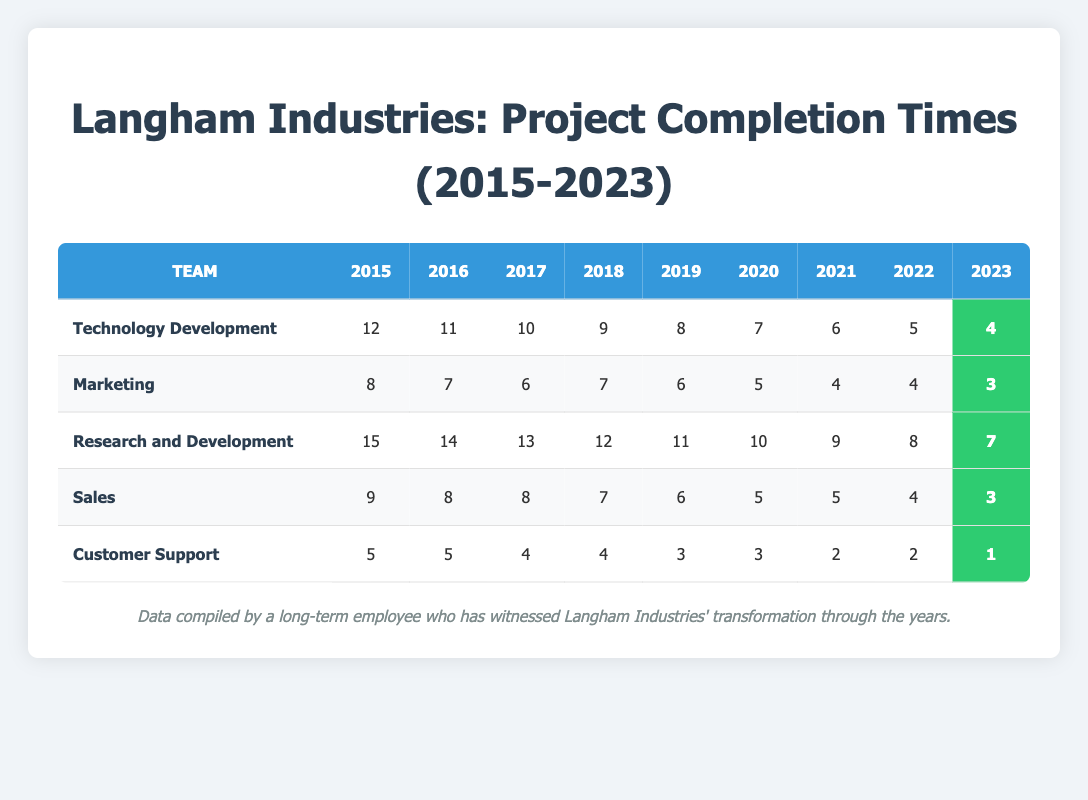What is the average project completion time for the Marketing team in 2023? The completion time for Marketing in 2023 is directly available in the table as 3.
Answer: 3 Which team had the longest average project completion time in 2015? Looking at the table, the Research and Development team had a completion time of 15 in 2015, which is the highest among all teams.
Answer: Research and Development What is the total project completion time for the Technology Development team from 2015 to 2023? Summing the completion times for Technology Development: 12 + 11 + 10 + 9 + 8 + 7 + 6 + 5 + 4 = 72.
Answer: 72 Did the Customer Support team improve their project completion time from 2015 to 2023? In 2015, the time was 5, and it decreased to 1 in 2023, indicating a significant improvement in efficiency.
Answer: Yes What was the difference in project completion times between the Marketing team and the Sales team in 2022? The completion time for Marketing in 2022 is 4, and for Sales, it is also 4. The difference is 4 - 4 = 0.
Answer: 0 Which team has the lowest project completion time in 2021? In 2021, Customer Support had the lowest completion time of 2, which is lower than all other teams.
Answer: Customer Support What is the average project completion time for the Research and Development team from 2015 to 2023? Adding the completion times for Research and Development gives us: (15 + 14 + 13 + 12 + 11 + 10 + 9 + 8 + 7) = 99. Since there are 9 years, the average is 99 / 9 = 11.
Answer: 11 Which years showed a completion time of 5 for the Marketing team? By examining the table, the Marketing team had a completion time of 5 in the years 2020 and 2022.
Answer: 2020, 2022 How many teams had a completion time of 4 in 2018? Reviewing the table shows that both the Marketing team and the Research and Development team had a completion time of 4 in 2018, so there are 2 teams.
Answer: 2 